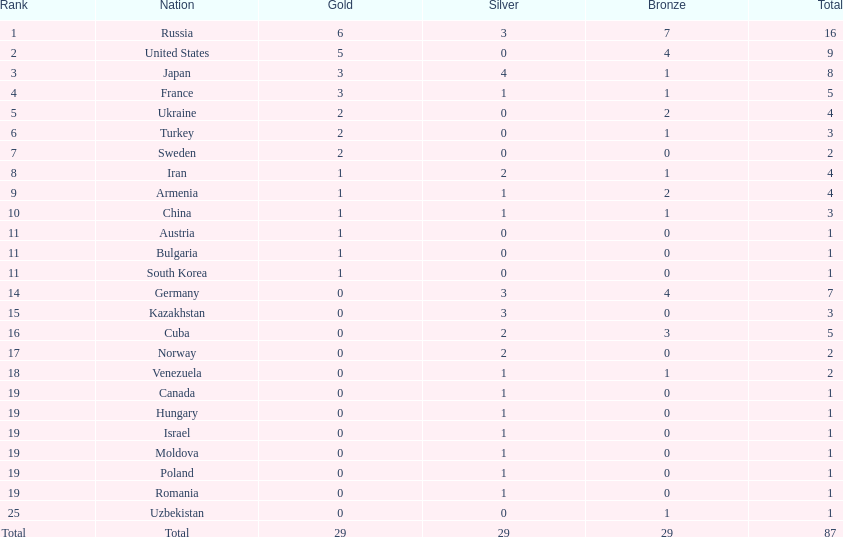What is the total amount of nations with more than 5 bronze medals? 1. 